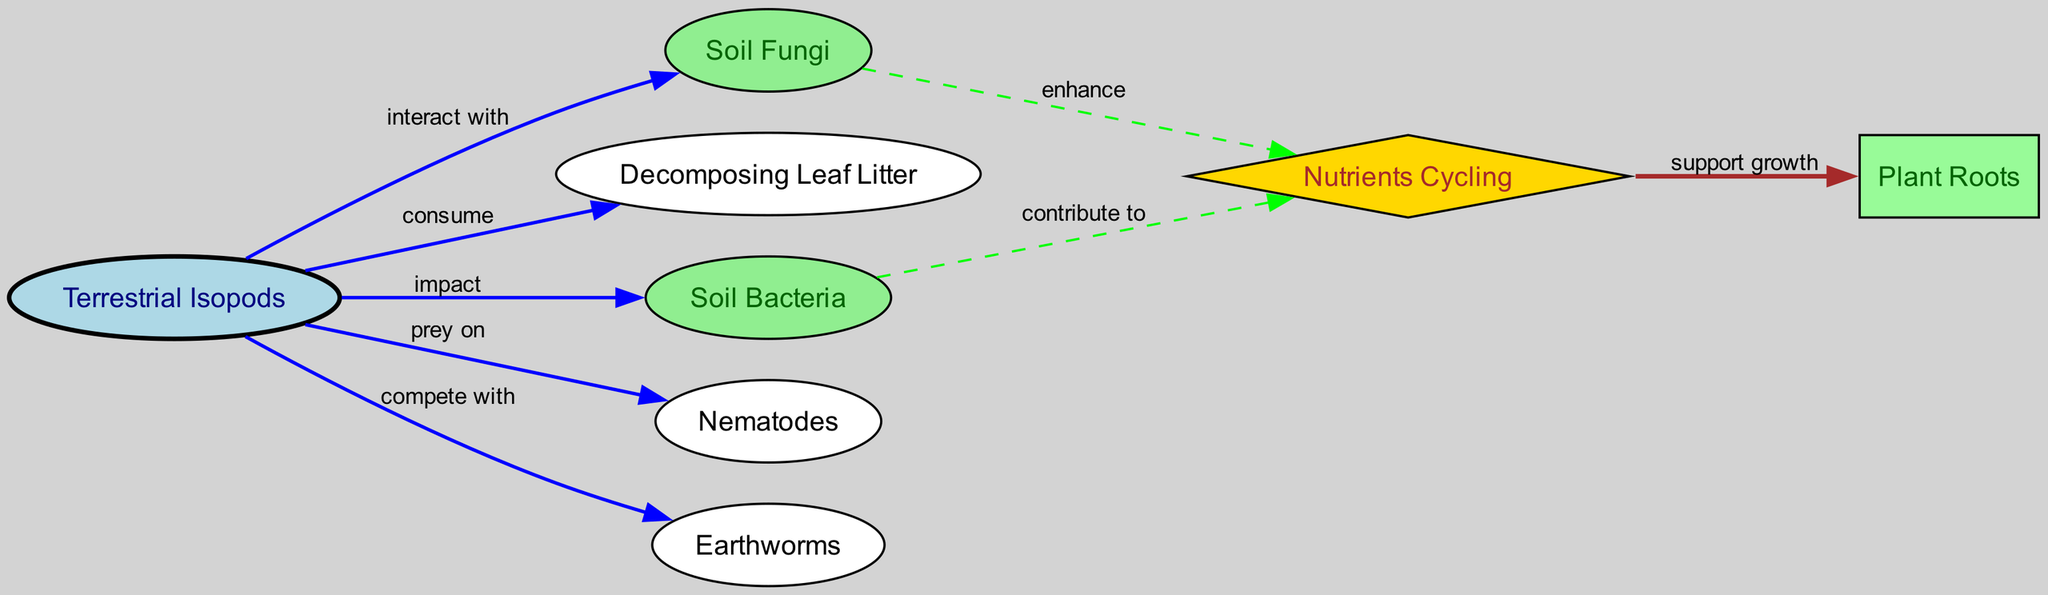What is the total number of nodes in the diagram? There are 8 unique entities (nodes) in the diagram, which include Terrestrial Isopods, Soil Fungi, Decomposing Leaf Litter, Soil Bacteria, Nematodes, Earthworms, Nutrients Cycling, and Plant Roots.
Answer: 8 What relationship exists between Terrestrial Isopods and Decomposing Leaf Litter? The diagram shows an edge labeled "consume" connecting Terrestrial Isopods to Decomposing Leaf Litter, indicating that isopods consume leaf litter.
Answer: consume Which organism do Terrestrial Isopods prey on? The directed edge labeled "prey on" connects Terrestrial Isopods to Nematodes, indicating that they are predators of nematodes.
Answer: Nematodes How do Soil Bacteria contribute to Nutrients Cycling? There is an edge labeled "contribute to" connecting Soil Bacteria to Nutrients Cycling, demonstrating that bacteria are involved in the nutrient recycling process in the soil.
Answer: contribute to What is the relationship between Nutrients Cycling and Plant Roots? There is an edge that shows Nutrients Cycling "support growth" for Plant Roots, indicating that nutrient cycling enhances the growth of plant roots.
Answer: support growth Which organisms do Terrestrial Isopods compete with? The directed edge labeled "compete with" shows that Terrestrial Isopods compete with Earthworms for resources, showing interaction between these two organisms.
Answer: Earthworms Which node enhances Nutrients Cycling? The diagram indicates that Soil Fungi "enhance" Nutrients Cycling, meaning fungi have a positive role in nutrient recycling.
Answer: Soil Fungi What types of nodes are connected to Nutrients Cycling? The diagram shows connections from Soil Bacteria (contribute to), Soil Fungi (enhance), and from Nutrients Cycling to Plant Roots (support growth), indicating multiple interactions with nutrients cycling.
Answer: Soil Bacteria, Soil Fungi, Plant Roots What type of graph is used to display the interactions of Terrestrial Isopods? The structure used to represent these interactions is a directed graph, as it shows relationships with arrows indicating directionality among the nodes.
Answer: directed graph 